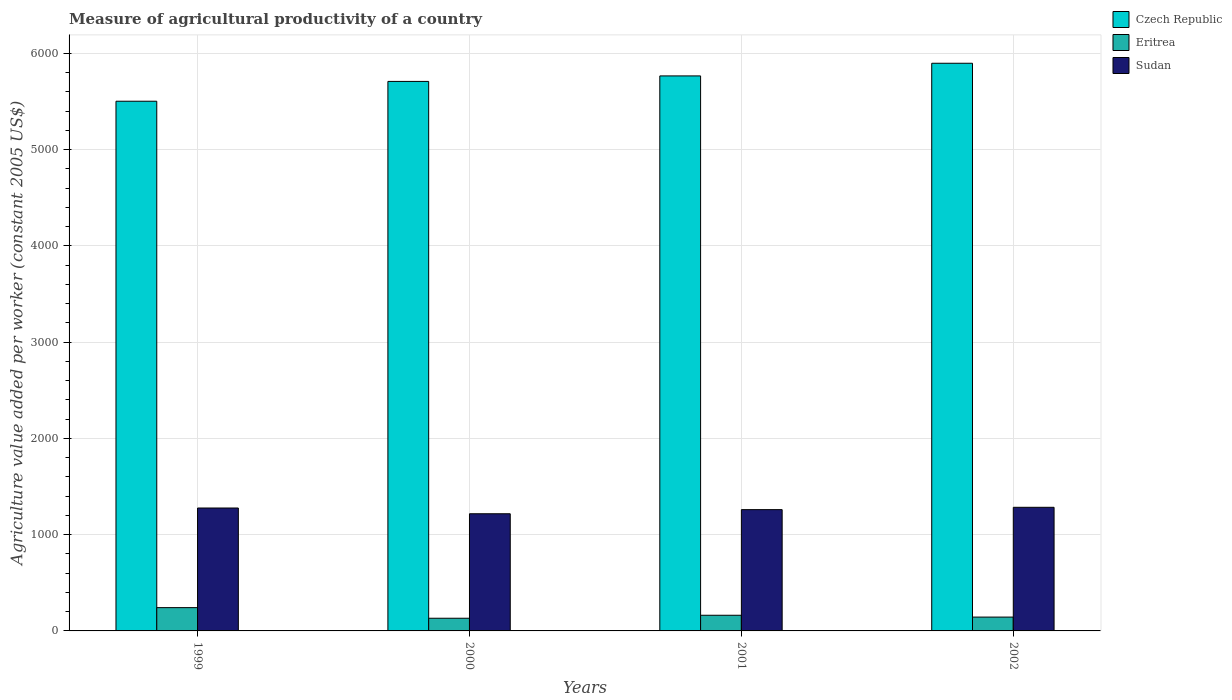How many groups of bars are there?
Make the answer very short. 4. Are the number of bars per tick equal to the number of legend labels?
Offer a terse response. Yes. Are the number of bars on each tick of the X-axis equal?
Ensure brevity in your answer.  Yes. How many bars are there on the 1st tick from the right?
Your answer should be compact. 3. What is the label of the 1st group of bars from the left?
Your answer should be compact. 1999. What is the measure of agricultural productivity in Sudan in 1999?
Your answer should be very brief. 1277.08. Across all years, what is the maximum measure of agricultural productivity in Eritrea?
Offer a terse response. 241.96. Across all years, what is the minimum measure of agricultural productivity in Sudan?
Make the answer very short. 1217.34. In which year was the measure of agricultural productivity in Sudan maximum?
Keep it short and to the point. 2002. In which year was the measure of agricultural productivity in Sudan minimum?
Give a very brief answer. 2000. What is the total measure of agricultural productivity in Sudan in the graph?
Provide a short and direct response. 5038.89. What is the difference between the measure of agricultural productivity in Eritrea in 2001 and that in 2002?
Your answer should be compact. 18.95. What is the difference between the measure of agricultural productivity in Czech Republic in 2000 and the measure of agricultural productivity in Eritrea in 1999?
Offer a terse response. 5467.4. What is the average measure of agricultural productivity in Sudan per year?
Offer a terse response. 1259.72. In the year 2000, what is the difference between the measure of agricultural productivity in Sudan and measure of agricultural productivity in Czech Republic?
Give a very brief answer. -4492.02. What is the ratio of the measure of agricultural productivity in Czech Republic in 1999 to that in 2001?
Provide a short and direct response. 0.95. Is the measure of agricultural productivity in Czech Republic in 2000 less than that in 2001?
Offer a terse response. Yes. What is the difference between the highest and the second highest measure of agricultural productivity in Czech Republic?
Give a very brief answer. 131.53. What is the difference between the highest and the lowest measure of agricultural productivity in Eritrea?
Provide a short and direct response. 110.26. In how many years, is the measure of agricultural productivity in Sudan greater than the average measure of agricultural productivity in Sudan taken over all years?
Offer a terse response. 3. Is the sum of the measure of agricultural productivity in Czech Republic in 1999 and 2000 greater than the maximum measure of agricultural productivity in Sudan across all years?
Ensure brevity in your answer.  Yes. What does the 3rd bar from the left in 1999 represents?
Your answer should be compact. Sudan. What does the 1st bar from the right in 2000 represents?
Your response must be concise. Sudan. Is it the case that in every year, the sum of the measure of agricultural productivity in Czech Republic and measure of agricultural productivity in Eritrea is greater than the measure of agricultural productivity in Sudan?
Offer a terse response. Yes. Does the graph contain any zero values?
Ensure brevity in your answer.  No. Does the graph contain grids?
Keep it short and to the point. Yes. What is the title of the graph?
Provide a succinct answer. Measure of agricultural productivity of a country. What is the label or title of the Y-axis?
Keep it short and to the point. Agriculture value added per worker (constant 2005 US$). What is the Agriculture value added per worker (constant 2005 US$) of Czech Republic in 1999?
Your answer should be very brief. 5503.49. What is the Agriculture value added per worker (constant 2005 US$) of Eritrea in 1999?
Offer a terse response. 241.96. What is the Agriculture value added per worker (constant 2005 US$) in Sudan in 1999?
Give a very brief answer. 1277.08. What is the Agriculture value added per worker (constant 2005 US$) in Czech Republic in 2000?
Provide a short and direct response. 5709.36. What is the Agriculture value added per worker (constant 2005 US$) in Eritrea in 2000?
Provide a succinct answer. 131.7. What is the Agriculture value added per worker (constant 2005 US$) in Sudan in 2000?
Give a very brief answer. 1217.34. What is the Agriculture value added per worker (constant 2005 US$) in Czech Republic in 2001?
Offer a terse response. 5766.48. What is the Agriculture value added per worker (constant 2005 US$) of Eritrea in 2001?
Your response must be concise. 162.77. What is the Agriculture value added per worker (constant 2005 US$) of Sudan in 2001?
Keep it short and to the point. 1260.14. What is the Agriculture value added per worker (constant 2005 US$) of Czech Republic in 2002?
Offer a very short reply. 5898.01. What is the Agriculture value added per worker (constant 2005 US$) of Eritrea in 2002?
Your answer should be compact. 143.81. What is the Agriculture value added per worker (constant 2005 US$) of Sudan in 2002?
Keep it short and to the point. 1284.33. Across all years, what is the maximum Agriculture value added per worker (constant 2005 US$) in Czech Republic?
Provide a succinct answer. 5898.01. Across all years, what is the maximum Agriculture value added per worker (constant 2005 US$) of Eritrea?
Offer a terse response. 241.96. Across all years, what is the maximum Agriculture value added per worker (constant 2005 US$) of Sudan?
Give a very brief answer. 1284.33. Across all years, what is the minimum Agriculture value added per worker (constant 2005 US$) in Czech Republic?
Your answer should be very brief. 5503.49. Across all years, what is the minimum Agriculture value added per worker (constant 2005 US$) in Eritrea?
Keep it short and to the point. 131.7. Across all years, what is the minimum Agriculture value added per worker (constant 2005 US$) in Sudan?
Offer a very short reply. 1217.34. What is the total Agriculture value added per worker (constant 2005 US$) in Czech Republic in the graph?
Keep it short and to the point. 2.29e+04. What is the total Agriculture value added per worker (constant 2005 US$) in Eritrea in the graph?
Provide a succinct answer. 680.23. What is the total Agriculture value added per worker (constant 2005 US$) of Sudan in the graph?
Offer a very short reply. 5038.89. What is the difference between the Agriculture value added per worker (constant 2005 US$) in Czech Republic in 1999 and that in 2000?
Offer a terse response. -205.87. What is the difference between the Agriculture value added per worker (constant 2005 US$) in Eritrea in 1999 and that in 2000?
Your response must be concise. 110.26. What is the difference between the Agriculture value added per worker (constant 2005 US$) in Sudan in 1999 and that in 2000?
Make the answer very short. 59.74. What is the difference between the Agriculture value added per worker (constant 2005 US$) in Czech Republic in 1999 and that in 2001?
Offer a terse response. -262.99. What is the difference between the Agriculture value added per worker (constant 2005 US$) of Eritrea in 1999 and that in 2001?
Provide a succinct answer. 79.19. What is the difference between the Agriculture value added per worker (constant 2005 US$) in Sudan in 1999 and that in 2001?
Offer a very short reply. 16.94. What is the difference between the Agriculture value added per worker (constant 2005 US$) of Czech Republic in 1999 and that in 2002?
Provide a succinct answer. -394.52. What is the difference between the Agriculture value added per worker (constant 2005 US$) in Eritrea in 1999 and that in 2002?
Provide a short and direct response. 98.15. What is the difference between the Agriculture value added per worker (constant 2005 US$) in Sudan in 1999 and that in 2002?
Your response must be concise. -7.24. What is the difference between the Agriculture value added per worker (constant 2005 US$) in Czech Republic in 2000 and that in 2001?
Your answer should be compact. -57.12. What is the difference between the Agriculture value added per worker (constant 2005 US$) in Eritrea in 2000 and that in 2001?
Ensure brevity in your answer.  -31.07. What is the difference between the Agriculture value added per worker (constant 2005 US$) of Sudan in 2000 and that in 2001?
Provide a succinct answer. -42.8. What is the difference between the Agriculture value added per worker (constant 2005 US$) in Czech Republic in 2000 and that in 2002?
Ensure brevity in your answer.  -188.65. What is the difference between the Agriculture value added per worker (constant 2005 US$) in Eritrea in 2000 and that in 2002?
Your answer should be very brief. -12.11. What is the difference between the Agriculture value added per worker (constant 2005 US$) of Sudan in 2000 and that in 2002?
Give a very brief answer. -66.98. What is the difference between the Agriculture value added per worker (constant 2005 US$) of Czech Republic in 2001 and that in 2002?
Ensure brevity in your answer.  -131.53. What is the difference between the Agriculture value added per worker (constant 2005 US$) of Eritrea in 2001 and that in 2002?
Give a very brief answer. 18.95. What is the difference between the Agriculture value added per worker (constant 2005 US$) in Sudan in 2001 and that in 2002?
Keep it short and to the point. -24.18. What is the difference between the Agriculture value added per worker (constant 2005 US$) of Czech Republic in 1999 and the Agriculture value added per worker (constant 2005 US$) of Eritrea in 2000?
Give a very brief answer. 5371.79. What is the difference between the Agriculture value added per worker (constant 2005 US$) in Czech Republic in 1999 and the Agriculture value added per worker (constant 2005 US$) in Sudan in 2000?
Provide a succinct answer. 4286.14. What is the difference between the Agriculture value added per worker (constant 2005 US$) of Eritrea in 1999 and the Agriculture value added per worker (constant 2005 US$) of Sudan in 2000?
Your response must be concise. -975.39. What is the difference between the Agriculture value added per worker (constant 2005 US$) in Czech Republic in 1999 and the Agriculture value added per worker (constant 2005 US$) in Eritrea in 2001?
Your answer should be compact. 5340.72. What is the difference between the Agriculture value added per worker (constant 2005 US$) in Czech Republic in 1999 and the Agriculture value added per worker (constant 2005 US$) in Sudan in 2001?
Your answer should be compact. 4243.35. What is the difference between the Agriculture value added per worker (constant 2005 US$) in Eritrea in 1999 and the Agriculture value added per worker (constant 2005 US$) in Sudan in 2001?
Make the answer very short. -1018.18. What is the difference between the Agriculture value added per worker (constant 2005 US$) in Czech Republic in 1999 and the Agriculture value added per worker (constant 2005 US$) in Eritrea in 2002?
Ensure brevity in your answer.  5359.68. What is the difference between the Agriculture value added per worker (constant 2005 US$) in Czech Republic in 1999 and the Agriculture value added per worker (constant 2005 US$) in Sudan in 2002?
Your answer should be compact. 4219.16. What is the difference between the Agriculture value added per worker (constant 2005 US$) in Eritrea in 1999 and the Agriculture value added per worker (constant 2005 US$) in Sudan in 2002?
Give a very brief answer. -1042.37. What is the difference between the Agriculture value added per worker (constant 2005 US$) of Czech Republic in 2000 and the Agriculture value added per worker (constant 2005 US$) of Eritrea in 2001?
Make the answer very short. 5546.59. What is the difference between the Agriculture value added per worker (constant 2005 US$) of Czech Republic in 2000 and the Agriculture value added per worker (constant 2005 US$) of Sudan in 2001?
Offer a very short reply. 4449.22. What is the difference between the Agriculture value added per worker (constant 2005 US$) of Eritrea in 2000 and the Agriculture value added per worker (constant 2005 US$) of Sudan in 2001?
Your answer should be very brief. -1128.44. What is the difference between the Agriculture value added per worker (constant 2005 US$) of Czech Republic in 2000 and the Agriculture value added per worker (constant 2005 US$) of Eritrea in 2002?
Give a very brief answer. 5565.55. What is the difference between the Agriculture value added per worker (constant 2005 US$) in Czech Republic in 2000 and the Agriculture value added per worker (constant 2005 US$) in Sudan in 2002?
Your response must be concise. 4425.03. What is the difference between the Agriculture value added per worker (constant 2005 US$) in Eritrea in 2000 and the Agriculture value added per worker (constant 2005 US$) in Sudan in 2002?
Your answer should be compact. -1152.63. What is the difference between the Agriculture value added per worker (constant 2005 US$) in Czech Republic in 2001 and the Agriculture value added per worker (constant 2005 US$) in Eritrea in 2002?
Make the answer very short. 5622.67. What is the difference between the Agriculture value added per worker (constant 2005 US$) of Czech Republic in 2001 and the Agriculture value added per worker (constant 2005 US$) of Sudan in 2002?
Provide a succinct answer. 4482.16. What is the difference between the Agriculture value added per worker (constant 2005 US$) of Eritrea in 2001 and the Agriculture value added per worker (constant 2005 US$) of Sudan in 2002?
Make the answer very short. -1121.56. What is the average Agriculture value added per worker (constant 2005 US$) in Czech Republic per year?
Provide a short and direct response. 5719.33. What is the average Agriculture value added per worker (constant 2005 US$) in Eritrea per year?
Give a very brief answer. 170.06. What is the average Agriculture value added per worker (constant 2005 US$) of Sudan per year?
Keep it short and to the point. 1259.72. In the year 1999, what is the difference between the Agriculture value added per worker (constant 2005 US$) of Czech Republic and Agriculture value added per worker (constant 2005 US$) of Eritrea?
Provide a succinct answer. 5261.53. In the year 1999, what is the difference between the Agriculture value added per worker (constant 2005 US$) of Czech Republic and Agriculture value added per worker (constant 2005 US$) of Sudan?
Make the answer very short. 4226.41. In the year 1999, what is the difference between the Agriculture value added per worker (constant 2005 US$) in Eritrea and Agriculture value added per worker (constant 2005 US$) in Sudan?
Your response must be concise. -1035.12. In the year 2000, what is the difference between the Agriculture value added per worker (constant 2005 US$) in Czech Republic and Agriculture value added per worker (constant 2005 US$) in Eritrea?
Provide a succinct answer. 5577.66. In the year 2000, what is the difference between the Agriculture value added per worker (constant 2005 US$) in Czech Republic and Agriculture value added per worker (constant 2005 US$) in Sudan?
Your answer should be very brief. 4492.02. In the year 2000, what is the difference between the Agriculture value added per worker (constant 2005 US$) in Eritrea and Agriculture value added per worker (constant 2005 US$) in Sudan?
Offer a very short reply. -1085.65. In the year 2001, what is the difference between the Agriculture value added per worker (constant 2005 US$) in Czech Republic and Agriculture value added per worker (constant 2005 US$) in Eritrea?
Give a very brief answer. 5603.72. In the year 2001, what is the difference between the Agriculture value added per worker (constant 2005 US$) in Czech Republic and Agriculture value added per worker (constant 2005 US$) in Sudan?
Offer a very short reply. 4506.34. In the year 2001, what is the difference between the Agriculture value added per worker (constant 2005 US$) in Eritrea and Agriculture value added per worker (constant 2005 US$) in Sudan?
Keep it short and to the point. -1097.38. In the year 2002, what is the difference between the Agriculture value added per worker (constant 2005 US$) in Czech Republic and Agriculture value added per worker (constant 2005 US$) in Eritrea?
Keep it short and to the point. 5754.2. In the year 2002, what is the difference between the Agriculture value added per worker (constant 2005 US$) in Czech Republic and Agriculture value added per worker (constant 2005 US$) in Sudan?
Provide a short and direct response. 4613.68. In the year 2002, what is the difference between the Agriculture value added per worker (constant 2005 US$) of Eritrea and Agriculture value added per worker (constant 2005 US$) of Sudan?
Give a very brief answer. -1140.51. What is the ratio of the Agriculture value added per worker (constant 2005 US$) in Czech Republic in 1999 to that in 2000?
Your answer should be very brief. 0.96. What is the ratio of the Agriculture value added per worker (constant 2005 US$) in Eritrea in 1999 to that in 2000?
Your answer should be very brief. 1.84. What is the ratio of the Agriculture value added per worker (constant 2005 US$) in Sudan in 1999 to that in 2000?
Provide a succinct answer. 1.05. What is the ratio of the Agriculture value added per worker (constant 2005 US$) in Czech Republic in 1999 to that in 2001?
Provide a short and direct response. 0.95. What is the ratio of the Agriculture value added per worker (constant 2005 US$) in Eritrea in 1999 to that in 2001?
Provide a short and direct response. 1.49. What is the ratio of the Agriculture value added per worker (constant 2005 US$) of Sudan in 1999 to that in 2001?
Offer a terse response. 1.01. What is the ratio of the Agriculture value added per worker (constant 2005 US$) in Czech Republic in 1999 to that in 2002?
Your answer should be compact. 0.93. What is the ratio of the Agriculture value added per worker (constant 2005 US$) in Eritrea in 1999 to that in 2002?
Keep it short and to the point. 1.68. What is the ratio of the Agriculture value added per worker (constant 2005 US$) of Czech Republic in 2000 to that in 2001?
Give a very brief answer. 0.99. What is the ratio of the Agriculture value added per worker (constant 2005 US$) in Eritrea in 2000 to that in 2001?
Your answer should be very brief. 0.81. What is the ratio of the Agriculture value added per worker (constant 2005 US$) of Sudan in 2000 to that in 2001?
Ensure brevity in your answer.  0.97. What is the ratio of the Agriculture value added per worker (constant 2005 US$) of Eritrea in 2000 to that in 2002?
Make the answer very short. 0.92. What is the ratio of the Agriculture value added per worker (constant 2005 US$) of Sudan in 2000 to that in 2002?
Provide a short and direct response. 0.95. What is the ratio of the Agriculture value added per worker (constant 2005 US$) of Czech Republic in 2001 to that in 2002?
Your answer should be very brief. 0.98. What is the ratio of the Agriculture value added per worker (constant 2005 US$) in Eritrea in 2001 to that in 2002?
Your answer should be compact. 1.13. What is the ratio of the Agriculture value added per worker (constant 2005 US$) of Sudan in 2001 to that in 2002?
Offer a very short reply. 0.98. What is the difference between the highest and the second highest Agriculture value added per worker (constant 2005 US$) in Czech Republic?
Your response must be concise. 131.53. What is the difference between the highest and the second highest Agriculture value added per worker (constant 2005 US$) in Eritrea?
Offer a terse response. 79.19. What is the difference between the highest and the second highest Agriculture value added per worker (constant 2005 US$) in Sudan?
Provide a short and direct response. 7.24. What is the difference between the highest and the lowest Agriculture value added per worker (constant 2005 US$) of Czech Republic?
Make the answer very short. 394.52. What is the difference between the highest and the lowest Agriculture value added per worker (constant 2005 US$) in Eritrea?
Give a very brief answer. 110.26. What is the difference between the highest and the lowest Agriculture value added per worker (constant 2005 US$) in Sudan?
Provide a succinct answer. 66.98. 